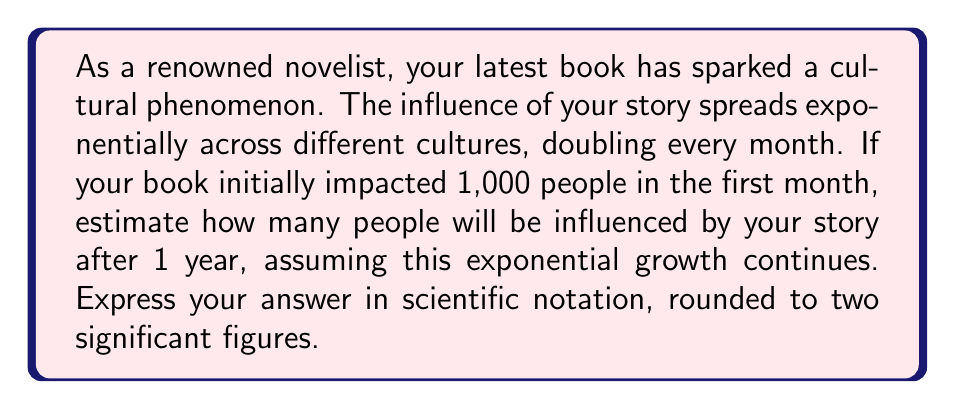Could you help me with this problem? Let's approach this step-by-step:

1) We start with 1,000 people influenced in the first month.

2) The influence doubles every month, which means we multiply by 2 each month.

3) There are 12 months in a year, so we need to double the number 12 times.

4) Mathematically, this can be expressed as:

   $1,000 \times 2^{12}$

5) Let's calculate:
   
   $1,000 \times 2^{12} = 1,000 \times 4,096 = 4,096,000$

6) Now, we need to express this in scientific notation with two significant figures:

   $4,096,000 \approx 4.1 \times 10^6$

Therefore, after one year, approximately $4.1 \times 10^6$ people will be influenced by your story.

This exponential growth model demonstrates the powerful spread of influential stories across cultures, reflecting how a novelist's words can have a far-reaching impact over time.
Answer: $4.1 \times 10^6$ people 